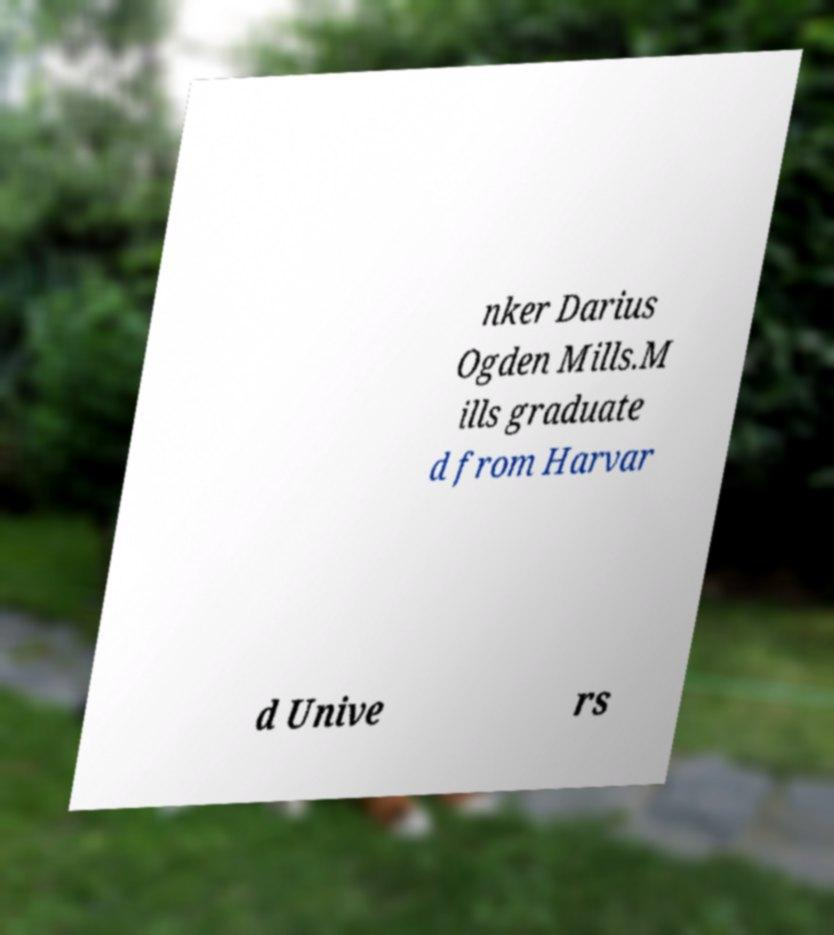There's text embedded in this image that I need extracted. Can you transcribe it verbatim? nker Darius Ogden Mills.M ills graduate d from Harvar d Unive rs 